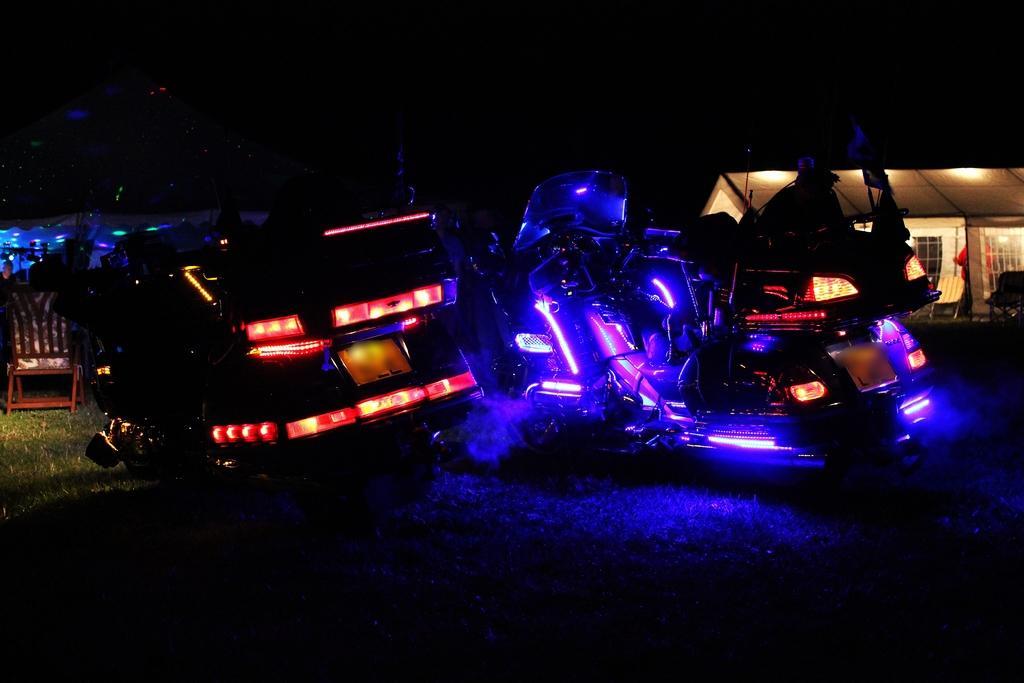How would you summarize this image in a sentence or two? In this picture we can see some machines and a chair on the grass path and behind the machines there is a house and a dark background. 